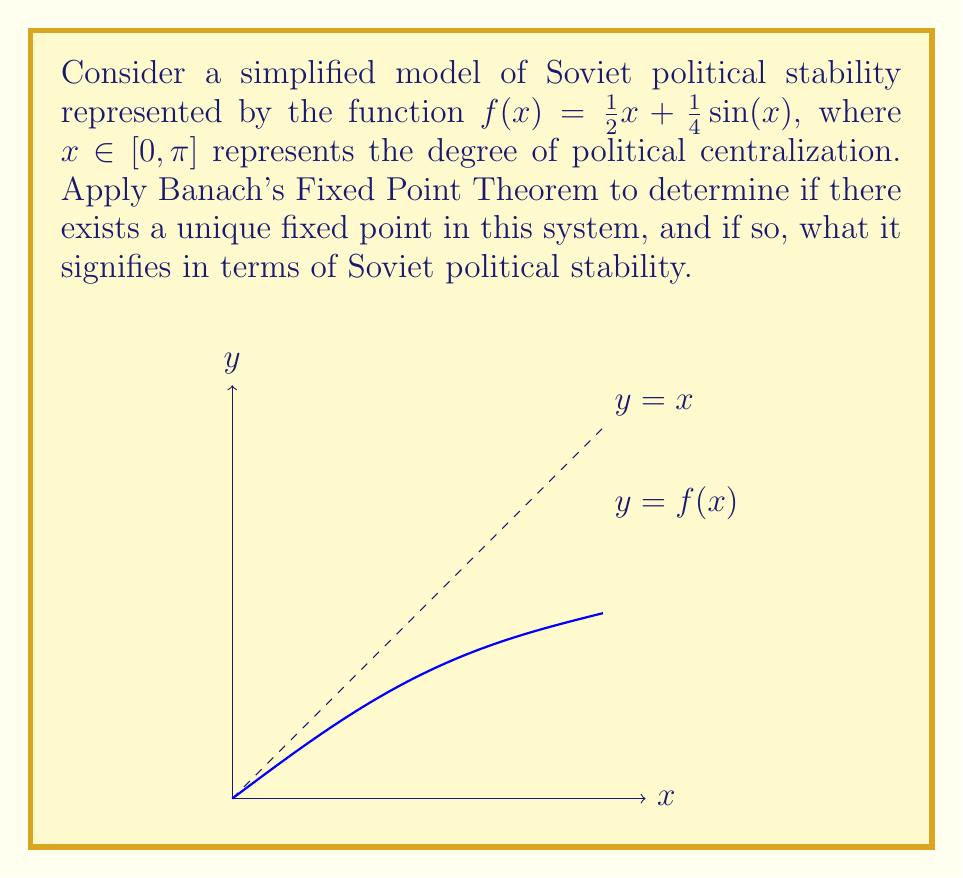Show me your answer to this math problem. To apply Banach's Fixed Point Theorem, we need to show that $f$ is a contraction mapping on $[0, \pi]$.

1) First, let's calculate $f'(x)$:
   $$f'(x) = \frac{1}{2} + \frac{1}{4}\cos(x)$$

2) For $x \in [0, \pi]$, we have:
   $$|f'(x)| = |\frac{1}{2} + \frac{1}{4}\cos(x)| \leq \frac{1}{2} + \frac{1}{4} = \frac{3}{4} < 1$$

3) Since $|f'(x)| < 1$ for all $x \in [0, \pi]$, $f$ is a contraction mapping on $[0, \pi]$.

4) $[0, \pi]$ is a closed and bounded interval in $\mathbb{R}$, so it's a complete metric space.

5) Therefore, by Banach's Fixed Point Theorem, $f$ has a unique fixed point in $[0, \pi]$.

6) This fixed point represents a stable equilibrium in the Soviet political system, where the degree of centralization remains constant under the given dynamics.

7) To find the fixed point, we can use the iterative method:
   $$x_{n+1} = f(x_n) = \frac{1}{2}x_n + \frac{1}{4}\sin(x_n)$$
   Starting with $x_0 = \frac{\pi}{2}$, we get:
   $x_1 \approx 1.5708$, $x_2 \approx 1.5451$, $x_3 \approx 1.5419$, ...

8) The fixed point converges to approximately 1.5416, which is about 0.4907π.

In the context of Soviet history, this unique fixed point suggests that under this simplified model, the Soviet political system would tend towards a specific degree of centralization, regardless of the initial conditions. This could be interpreted as a balance between centralized control and some degree of local autonomy.
Answer: Unique fixed point at $x \approx 1.5416$ (≈ 0.4907π), representing a stable equilibrium of political centralization. 